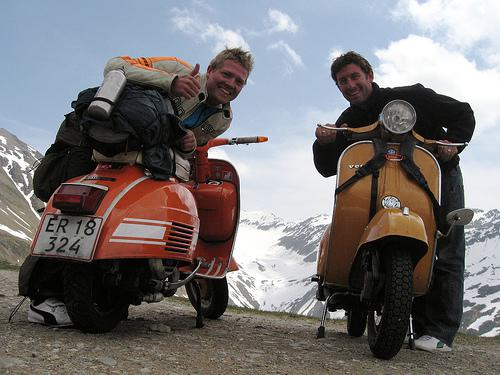How many motorbikes would there be in the image if someone added two more motorbikes in the picture? Currently, there are two motorbikes in the image. If someone added two more motorbikes, there would be a total of four motorbikes. 